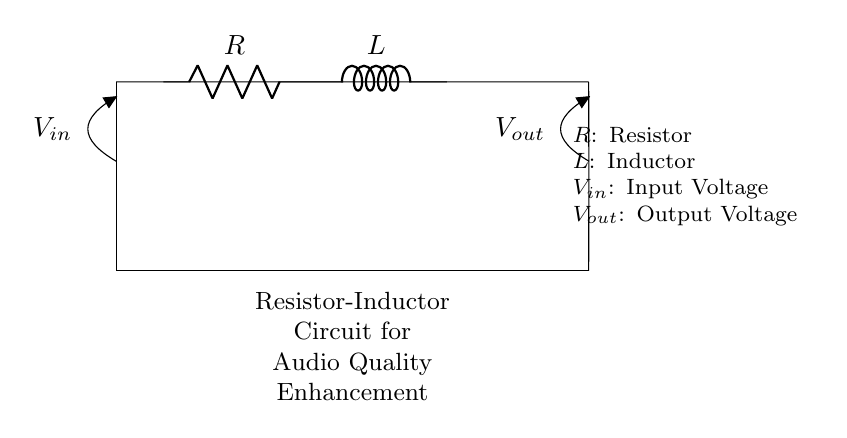What is the type of circuit depicted? The circuit is a resistor-inductor circuit, as indicated by the presence of both a resistor and an inductor in the schematic diagram.
Answer: Resistor-Inductor What are the components in this circuit? The components include a resistor (R) and an inductor (L), which are labeled in the circuit diagram.
Answer: Resistor and Inductor What does V_in represent? V_in represents the input voltage to the circuit, as shown by the labeled arrow pointing to the junction of the circuit where the input is applied.
Answer: Input Voltage What does V_out indicate? V_out indicates the output voltage of the circuit, shown in the diagram as the voltage at the output terminal after the resistor and inductor.
Answer: Output Voltage What is the effect of adding an inductor to a resistor circuit? Adding an inductor to a resistor circuit affects the frequency response and can improve audio quality by filtering certain frequencies, making the circuit suitable for audio applications.
Answer: Improves audio quality What is the function of the resistor in this circuit? The function of the resistor in this circuit is to limit the current flowing through the circuit, which plays a key role in controlling voltage and power dissipation across the components.
Answer: Current limiting How does the inductor impact the frequency response of this circuit? The inductor introduces inductive reactance, which opposes changes in current and can filter frequencies, allowing the circuit to enhance or suppress specific audio signals, thus improving sound quality.
Answer: Filters frequencies 